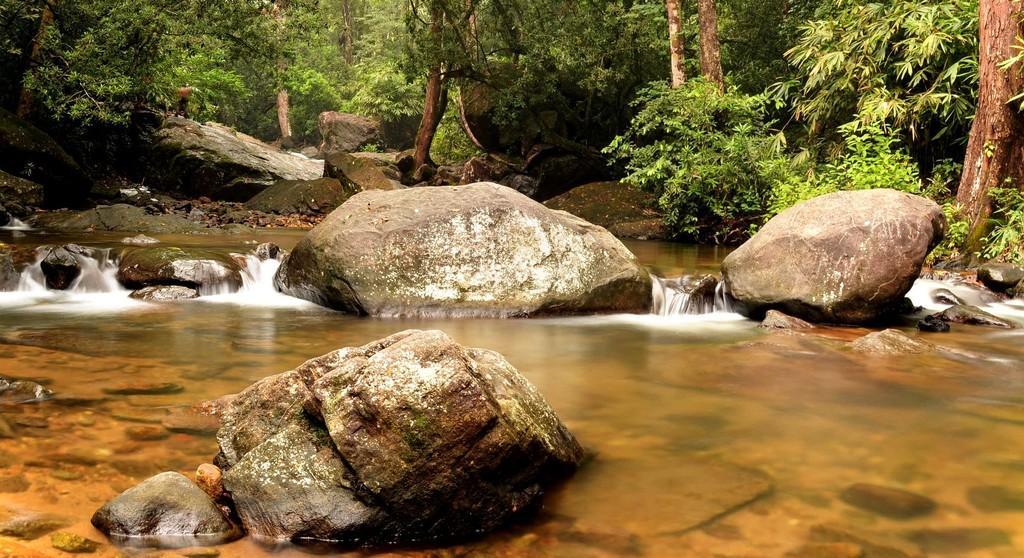Please provide a concise description of this image. At the bottom of the image I can see a river and there are some stones in the water. In the background, I can see many trees and rocks. 